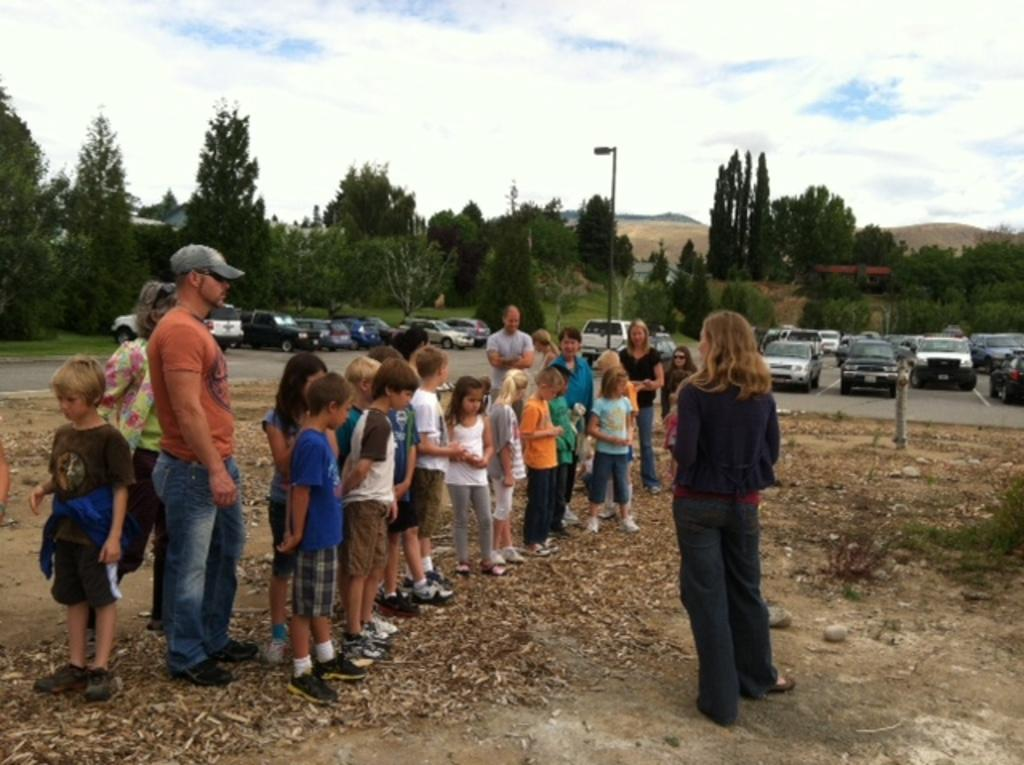What is happening in the middle of the image? There are people standing in the middle of the image. What can be seen behind the people? There are vehicles behind the people. What is visible in the background of the image? There are poles and trees in the background of the image. What is visible in the sky at the top of the image? There are clouds visible in the sky at the top of the image. What idea is being discussed by the people in the image? There is no indication of a discussion or idea being presented in the image; it simply shows people standing with vehicles and poles in the background. Is there a fire visible in the image? No, there is no fire present in the image. 